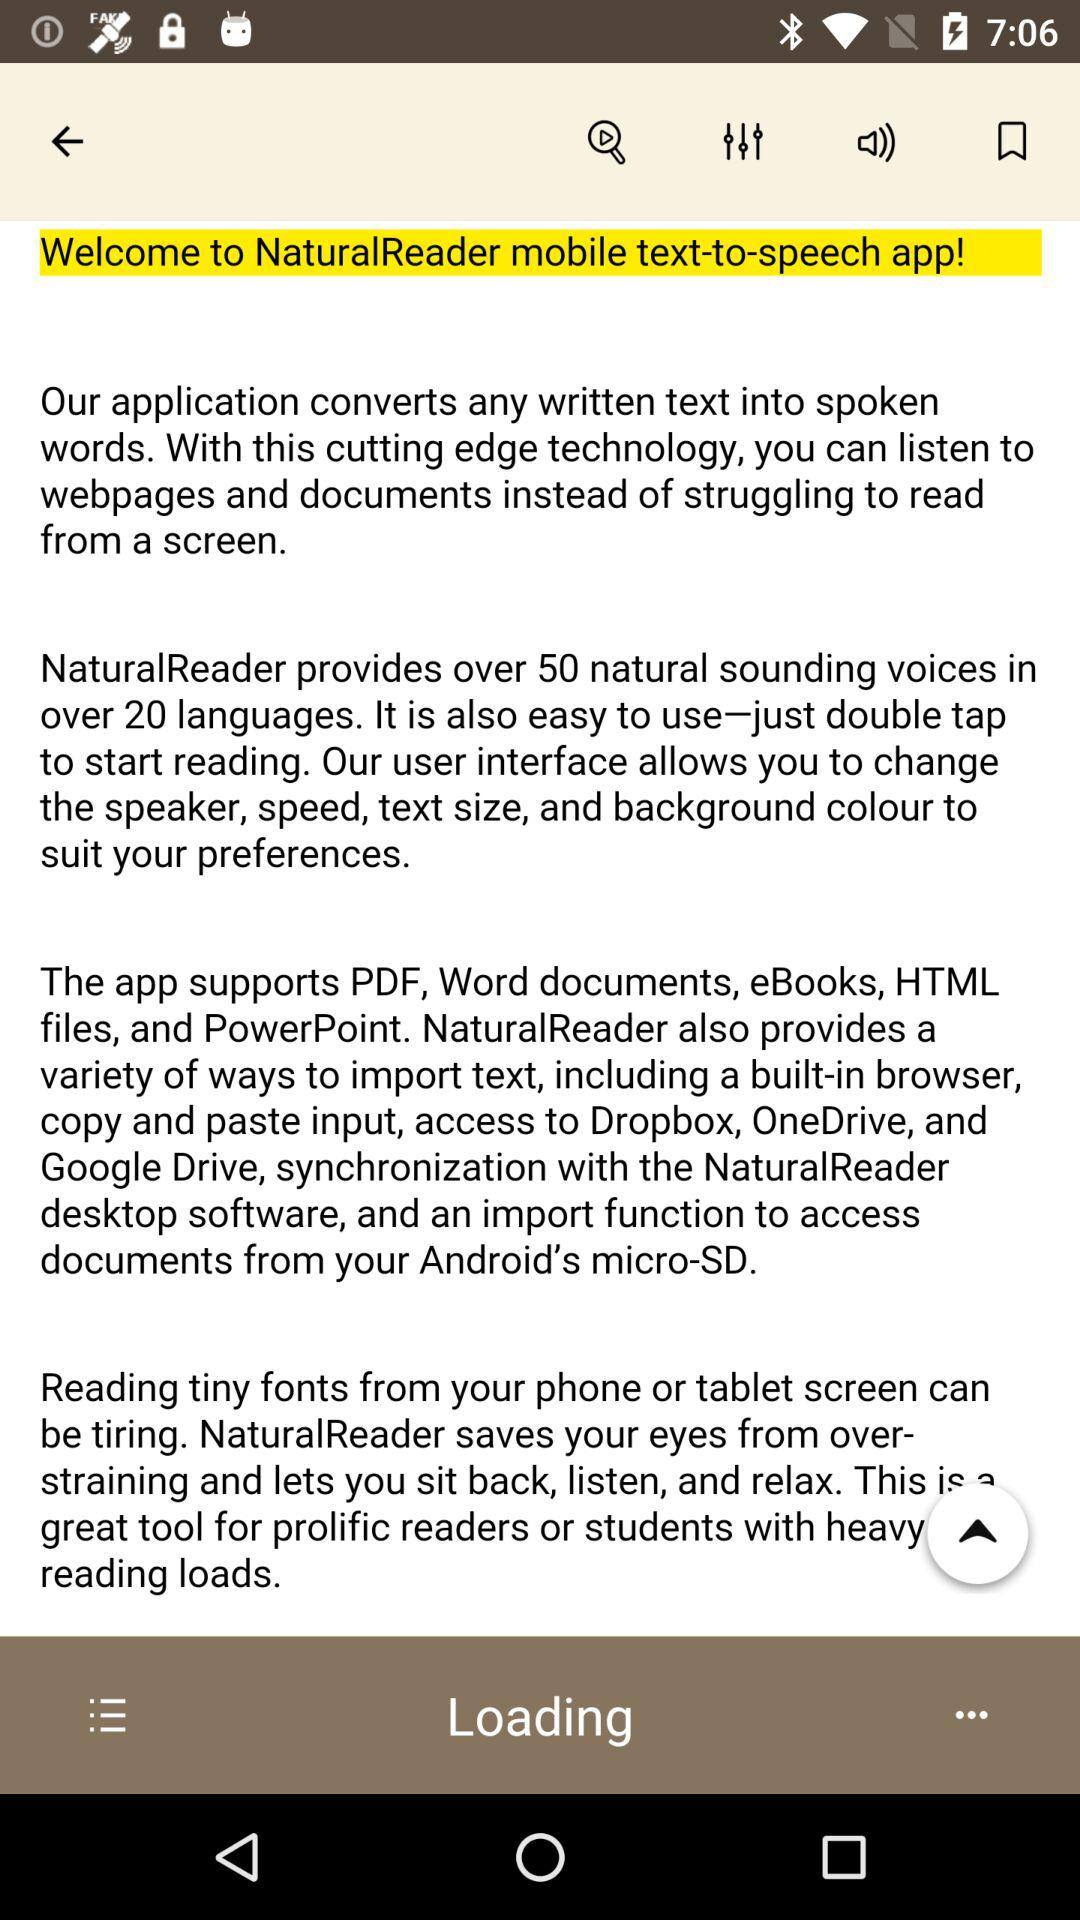How long does it take the application to read a chapter?
When the provided information is insufficient, respond with <no answer>. <no answer> 